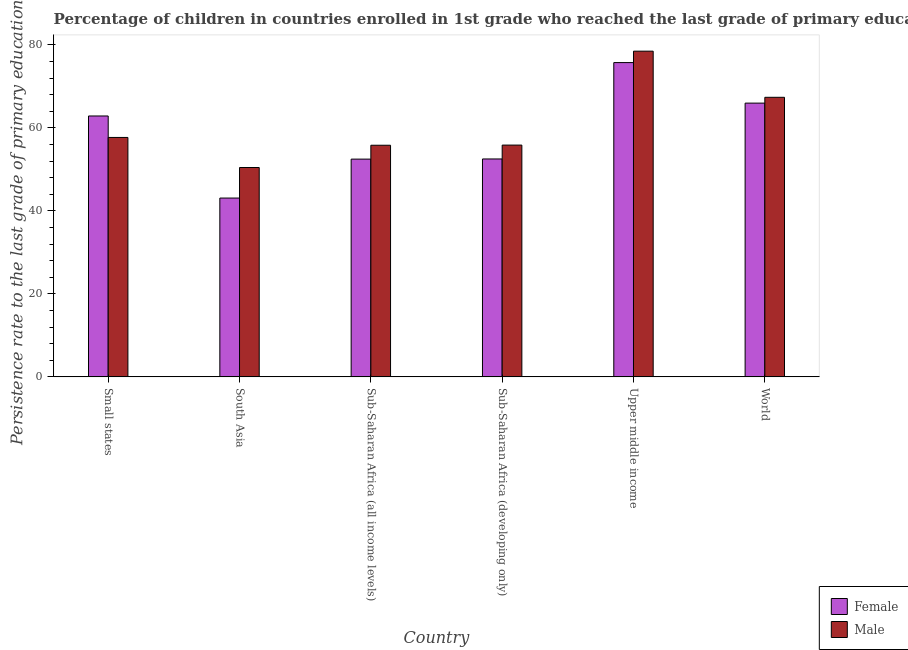Are the number of bars on each tick of the X-axis equal?
Your answer should be compact. Yes. What is the label of the 3rd group of bars from the left?
Offer a terse response. Sub-Saharan Africa (all income levels). What is the persistence rate of female students in Sub-Saharan Africa (all income levels)?
Offer a very short reply. 52.46. Across all countries, what is the maximum persistence rate of female students?
Your answer should be very brief. 75.72. Across all countries, what is the minimum persistence rate of female students?
Provide a short and direct response. 43.08. In which country was the persistence rate of male students maximum?
Ensure brevity in your answer.  Upper middle income. In which country was the persistence rate of male students minimum?
Provide a short and direct response. South Asia. What is the total persistence rate of male students in the graph?
Make the answer very short. 365.6. What is the difference between the persistence rate of female students in South Asia and that in World?
Make the answer very short. -22.87. What is the difference between the persistence rate of male students in South Asia and the persistence rate of female students in World?
Your answer should be very brief. -15.51. What is the average persistence rate of male students per country?
Offer a very short reply. 60.93. What is the difference between the persistence rate of male students and persistence rate of female students in South Asia?
Give a very brief answer. 7.36. What is the ratio of the persistence rate of female students in Sub-Saharan Africa (all income levels) to that in Sub-Saharan Africa (developing only)?
Your answer should be compact. 1. Is the persistence rate of female students in South Asia less than that in Sub-Saharan Africa (all income levels)?
Provide a succinct answer. Yes. Is the difference between the persistence rate of female students in Sub-Saharan Africa (all income levels) and World greater than the difference between the persistence rate of male students in Sub-Saharan Africa (all income levels) and World?
Ensure brevity in your answer.  No. What is the difference between the highest and the second highest persistence rate of female students?
Your response must be concise. 9.77. What is the difference between the highest and the lowest persistence rate of male students?
Ensure brevity in your answer.  28.03. Is the sum of the persistence rate of male students in Sub-Saharan Africa (all income levels) and Upper middle income greater than the maximum persistence rate of female students across all countries?
Your response must be concise. Yes. What does the 1st bar from the left in Upper middle income represents?
Your answer should be compact. Female. What does the 1st bar from the right in Sub-Saharan Africa (developing only) represents?
Give a very brief answer. Male. Are all the bars in the graph horizontal?
Give a very brief answer. No. What is the difference between two consecutive major ticks on the Y-axis?
Your answer should be compact. 20. Are the values on the major ticks of Y-axis written in scientific E-notation?
Give a very brief answer. No. Where does the legend appear in the graph?
Ensure brevity in your answer.  Bottom right. How many legend labels are there?
Keep it short and to the point. 2. What is the title of the graph?
Give a very brief answer. Percentage of children in countries enrolled in 1st grade who reached the last grade of primary education. Does "All education staff compensation" appear as one of the legend labels in the graph?
Your response must be concise. No. What is the label or title of the Y-axis?
Keep it short and to the point. Persistence rate to the last grade of primary education (%). What is the Persistence rate to the last grade of primary education (%) of Female in Small states?
Give a very brief answer. 62.85. What is the Persistence rate to the last grade of primary education (%) in Male in Small states?
Offer a terse response. 57.68. What is the Persistence rate to the last grade of primary education (%) in Female in South Asia?
Provide a succinct answer. 43.08. What is the Persistence rate to the last grade of primary education (%) in Male in South Asia?
Give a very brief answer. 50.44. What is the Persistence rate to the last grade of primary education (%) in Female in Sub-Saharan Africa (all income levels)?
Make the answer very short. 52.46. What is the Persistence rate to the last grade of primary education (%) in Male in Sub-Saharan Africa (all income levels)?
Give a very brief answer. 55.81. What is the Persistence rate to the last grade of primary education (%) in Female in Sub-Saharan Africa (developing only)?
Make the answer very short. 52.5. What is the Persistence rate to the last grade of primary education (%) of Male in Sub-Saharan Africa (developing only)?
Ensure brevity in your answer.  55.84. What is the Persistence rate to the last grade of primary education (%) of Female in Upper middle income?
Make the answer very short. 75.72. What is the Persistence rate to the last grade of primary education (%) of Male in Upper middle income?
Provide a short and direct response. 78.47. What is the Persistence rate to the last grade of primary education (%) of Female in World?
Provide a short and direct response. 65.95. What is the Persistence rate to the last grade of primary education (%) of Male in World?
Your answer should be very brief. 67.35. Across all countries, what is the maximum Persistence rate to the last grade of primary education (%) of Female?
Keep it short and to the point. 75.72. Across all countries, what is the maximum Persistence rate to the last grade of primary education (%) of Male?
Offer a very short reply. 78.47. Across all countries, what is the minimum Persistence rate to the last grade of primary education (%) of Female?
Provide a succinct answer. 43.08. Across all countries, what is the minimum Persistence rate to the last grade of primary education (%) of Male?
Provide a succinct answer. 50.44. What is the total Persistence rate to the last grade of primary education (%) of Female in the graph?
Provide a short and direct response. 352.57. What is the total Persistence rate to the last grade of primary education (%) of Male in the graph?
Keep it short and to the point. 365.6. What is the difference between the Persistence rate to the last grade of primary education (%) of Female in Small states and that in South Asia?
Make the answer very short. 19.77. What is the difference between the Persistence rate to the last grade of primary education (%) in Male in Small states and that in South Asia?
Provide a short and direct response. 7.24. What is the difference between the Persistence rate to the last grade of primary education (%) in Female in Small states and that in Sub-Saharan Africa (all income levels)?
Your answer should be compact. 10.39. What is the difference between the Persistence rate to the last grade of primary education (%) of Male in Small states and that in Sub-Saharan Africa (all income levels)?
Provide a succinct answer. 1.88. What is the difference between the Persistence rate to the last grade of primary education (%) in Female in Small states and that in Sub-Saharan Africa (developing only)?
Keep it short and to the point. 10.35. What is the difference between the Persistence rate to the last grade of primary education (%) of Male in Small states and that in Sub-Saharan Africa (developing only)?
Give a very brief answer. 1.84. What is the difference between the Persistence rate to the last grade of primary education (%) in Female in Small states and that in Upper middle income?
Keep it short and to the point. -12.87. What is the difference between the Persistence rate to the last grade of primary education (%) of Male in Small states and that in Upper middle income?
Your answer should be very brief. -20.79. What is the difference between the Persistence rate to the last grade of primary education (%) of Female in Small states and that in World?
Your answer should be compact. -3.1. What is the difference between the Persistence rate to the last grade of primary education (%) in Male in Small states and that in World?
Offer a very short reply. -9.67. What is the difference between the Persistence rate to the last grade of primary education (%) in Female in South Asia and that in Sub-Saharan Africa (all income levels)?
Provide a short and direct response. -9.38. What is the difference between the Persistence rate to the last grade of primary education (%) of Male in South Asia and that in Sub-Saharan Africa (all income levels)?
Keep it short and to the point. -5.36. What is the difference between the Persistence rate to the last grade of primary education (%) in Female in South Asia and that in Sub-Saharan Africa (developing only)?
Provide a succinct answer. -9.42. What is the difference between the Persistence rate to the last grade of primary education (%) in Male in South Asia and that in Sub-Saharan Africa (developing only)?
Make the answer very short. -5.4. What is the difference between the Persistence rate to the last grade of primary education (%) of Female in South Asia and that in Upper middle income?
Ensure brevity in your answer.  -32.64. What is the difference between the Persistence rate to the last grade of primary education (%) in Male in South Asia and that in Upper middle income?
Your response must be concise. -28.03. What is the difference between the Persistence rate to the last grade of primary education (%) of Female in South Asia and that in World?
Your answer should be compact. -22.87. What is the difference between the Persistence rate to the last grade of primary education (%) of Male in South Asia and that in World?
Provide a short and direct response. -16.91. What is the difference between the Persistence rate to the last grade of primary education (%) in Female in Sub-Saharan Africa (all income levels) and that in Sub-Saharan Africa (developing only)?
Offer a very short reply. -0.04. What is the difference between the Persistence rate to the last grade of primary education (%) in Male in Sub-Saharan Africa (all income levels) and that in Sub-Saharan Africa (developing only)?
Make the answer very short. -0.04. What is the difference between the Persistence rate to the last grade of primary education (%) in Female in Sub-Saharan Africa (all income levels) and that in Upper middle income?
Your answer should be very brief. -23.26. What is the difference between the Persistence rate to the last grade of primary education (%) of Male in Sub-Saharan Africa (all income levels) and that in Upper middle income?
Provide a short and direct response. -22.67. What is the difference between the Persistence rate to the last grade of primary education (%) in Female in Sub-Saharan Africa (all income levels) and that in World?
Your answer should be very brief. -13.49. What is the difference between the Persistence rate to the last grade of primary education (%) of Male in Sub-Saharan Africa (all income levels) and that in World?
Offer a terse response. -11.55. What is the difference between the Persistence rate to the last grade of primary education (%) of Female in Sub-Saharan Africa (developing only) and that in Upper middle income?
Offer a terse response. -23.22. What is the difference between the Persistence rate to the last grade of primary education (%) in Male in Sub-Saharan Africa (developing only) and that in Upper middle income?
Give a very brief answer. -22.63. What is the difference between the Persistence rate to the last grade of primary education (%) in Female in Sub-Saharan Africa (developing only) and that in World?
Offer a terse response. -13.45. What is the difference between the Persistence rate to the last grade of primary education (%) of Male in Sub-Saharan Africa (developing only) and that in World?
Your response must be concise. -11.51. What is the difference between the Persistence rate to the last grade of primary education (%) in Female in Upper middle income and that in World?
Make the answer very short. 9.77. What is the difference between the Persistence rate to the last grade of primary education (%) in Male in Upper middle income and that in World?
Offer a terse response. 11.12. What is the difference between the Persistence rate to the last grade of primary education (%) in Female in Small states and the Persistence rate to the last grade of primary education (%) in Male in South Asia?
Give a very brief answer. 12.41. What is the difference between the Persistence rate to the last grade of primary education (%) in Female in Small states and the Persistence rate to the last grade of primary education (%) in Male in Sub-Saharan Africa (all income levels)?
Provide a short and direct response. 7.05. What is the difference between the Persistence rate to the last grade of primary education (%) of Female in Small states and the Persistence rate to the last grade of primary education (%) of Male in Sub-Saharan Africa (developing only)?
Give a very brief answer. 7.01. What is the difference between the Persistence rate to the last grade of primary education (%) in Female in Small states and the Persistence rate to the last grade of primary education (%) in Male in Upper middle income?
Ensure brevity in your answer.  -15.62. What is the difference between the Persistence rate to the last grade of primary education (%) of Female in Small states and the Persistence rate to the last grade of primary education (%) of Male in World?
Keep it short and to the point. -4.5. What is the difference between the Persistence rate to the last grade of primary education (%) in Female in South Asia and the Persistence rate to the last grade of primary education (%) in Male in Sub-Saharan Africa (all income levels)?
Your answer should be compact. -12.73. What is the difference between the Persistence rate to the last grade of primary education (%) of Female in South Asia and the Persistence rate to the last grade of primary education (%) of Male in Sub-Saharan Africa (developing only)?
Your answer should be very brief. -12.76. What is the difference between the Persistence rate to the last grade of primary education (%) of Female in South Asia and the Persistence rate to the last grade of primary education (%) of Male in Upper middle income?
Offer a very short reply. -35.39. What is the difference between the Persistence rate to the last grade of primary education (%) of Female in South Asia and the Persistence rate to the last grade of primary education (%) of Male in World?
Offer a terse response. -24.27. What is the difference between the Persistence rate to the last grade of primary education (%) of Female in Sub-Saharan Africa (all income levels) and the Persistence rate to the last grade of primary education (%) of Male in Sub-Saharan Africa (developing only)?
Provide a succinct answer. -3.38. What is the difference between the Persistence rate to the last grade of primary education (%) in Female in Sub-Saharan Africa (all income levels) and the Persistence rate to the last grade of primary education (%) in Male in Upper middle income?
Provide a short and direct response. -26.01. What is the difference between the Persistence rate to the last grade of primary education (%) of Female in Sub-Saharan Africa (all income levels) and the Persistence rate to the last grade of primary education (%) of Male in World?
Make the answer very short. -14.89. What is the difference between the Persistence rate to the last grade of primary education (%) in Female in Sub-Saharan Africa (developing only) and the Persistence rate to the last grade of primary education (%) in Male in Upper middle income?
Offer a very short reply. -25.97. What is the difference between the Persistence rate to the last grade of primary education (%) of Female in Sub-Saharan Africa (developing only) and the Persistence rate to the last grade of primary education (%) of Male in World?
Ensure brevity in your answer.  -14.85. What is the difference between the Persistence rate to the last grade of primary education (%) in Female in Upper middle income and the Persistence rate to the last grade of primary education (%) in Male in World?
Your answer should be compact. 8.37. What is the average Persistence rate to the last grade of primary education (%) of Female per country?
Offer a very short reply. 58.76. What is the average Persistence rate to the last grade of primary education (%) in Male per country?
Your response must be concise. 60.93. What is the difference between the Persistence rate to the last grade of primary education (%) of Female and Persistence rate to the last grade of primary education (%) of Male in Small states?
Offer a terse response. 5.17. What is the difference between the Persistence rate to the last grade of primary education (%) of Female and Persistence rate to the last grade of primary education (%) of Male in South Asia?
Offer a very short reply. -7.36. What is the difference between the Persistence rate to the last grade of primary education (%) of Female and Persistence rate to the last grade of primary education (%) of Male in Sub-Saharan Africa (all income levels)?
Offer a very short reply. -3.34. What is the difference between the Persistence rate to the last grade of primary education (%) in Female and Persistence rate to the last grade of primary education (%) in Male in Sub-Saharan Africa (developing only)?
Your answer should be very brief. -3.34. What is the difference between the Persistence rate to the last grade of primary education (%) of Female and Persistence rate to the last grade of primary education (%) of Male in Upper middle income?
Provide a succinct answer. -2.75. What is the difference between the Persistence rate to the last grade of primary education (%) of Female and Persistence rate to the last grade of primary education (%) of Male in World?
Your response must be concise. -1.4. What is the ratio of the Persistence rate to the last grade of primary education (%) of Female in Small states to that in South Asia?
Offer a terse response. 1.46. What is the ratio of the Persistence rate to the last grade of primary education (%) of Male in Small states to that in South Asia?
Make the answer very short. 1.14. What is the ratio of the Persistence rate to the last grade of primary education (%) in Female in Small states to that in Sub-Saharan Africa (all income levels)?
Offer a very short reply. 1.2. What is the ratio of the Persistence rate to the last grade of primary education (%) in Male in Small states to that in Sub-Saharan Africa (all income levels)?
Keep it short and to the point. 1.03. What is the ratio of the Persistence rate to the last grade of primary education (%) in Female in Small states to that in Sub-Saharan Africa (developing only)?
Your answer should be compact. 1.2. What is the ratio of the Persistence rate to the last grade of primary education (%) in Male in Small states to that in Sub-Saharan Africa (developing only)?
Your answer should be very brief. 1.03. What is the ratio of the Persistence rate to the last grade of primary education (%) of Female in Small states to that in Upper middle income?
Give a very brief answer. 0.83. What is the ratio of the Persistence rate to the last grade of primary education (%) in Male in Small states to that in Upper middle income?
Offer a terse response. 0.74. What is the ratio of the Persistence rate to the last grade of primary education (%) of Female in Small states to that in World?
Ensure brevity in your answer.  0.95. What is the ratio of the Persistence rate to the last grade of primary education (%) of Male in Small states to that in World?
Offer a terse response. 0.86. What is the ratio of the Persistence rate to the last grade of primary education (%) in Female in South Asia to that in Sub-Saharan Africa (all income levels)?
Offer a very short reply. 0.82. What is the ratio of the Persistence rate to the last grade of primary education (%) of Male in South Asia to that in Sub-Saharan Africa (all income levels)?
Your answer should be compact. 0.9. What is the ratio of the Persistence rate to the last grade of primary education (%) of Female in South Asia to that in Sub-Saharan Africa (developing only)?
Provide a succinct answer. 0.82. What is the ratio of the Persistence rate to the last grade of primary education (%) in Male in South Asia to that in Sub-Saharan Africa (developing only)?
Keep it short and to the point. 0.9. What is the ratio of the Persistence rate to the last grade of primary education (%) in Female in South Asia to that in Upper middle income?
Your response must be concise. 0.57. What is the ratio of the Persistence rate to the last grade of primary education (%) of Male in South Asia to that in Upper middle income?
Make the answer very short. 0.64. What is the ratio of the Persistence rate to the last grade of primary education (%) in Female in South Asia to that in World?
Your response must be concise. 0.65. What is the ratio of the Persistence rate to the last grade of primary education (%) in Male in South Asia to that in World?
Keep it short and to the point. 0.75. What is the ratio of the Persistence rate to the last grade of primary education (%) of Female in Sub-Saharan Africa (all income levels) to that in Sub-Saharan Africa (developing only)?
Keep it short and to the point. 1. What is the ratio of the Persistence rate to the last grade of primary education (%) in Male in Sub-Saharan Africa (all income levels) to that in Sub-Saharan Africa (developing only)?
Provide a short and direct response. 1. What is the ratio of the Persistence rate to the last grade of primary education (%) of Female in Sub-Saharan Africa (all income levels) to that in Upper middle income?
Offer a very short reply. 0.69. What is the ratio of the Persistence rate to the last grade of primary education (%) of Male in Sub-Saharan Africa (all income levels) to that in Upper middle income?
Provide a short and direct response. 0.71. What is the ratio of the Persistence rate to the last grade of primary education (%) of Female in Sub-Saharan Africa (all income levels) to that in World?
Offer a terse response. 0.8. What is the ratio of the Persistence rate to the last grade of primary education (%) in Male in Sub-Saharan Africa (all income levels) to that in World?
Offer a terse response. 0.83. What is the ratio of the Persistence rate to the last grade of primary education (%) in Female in Sub-Saharan Africa (developing only) to that in Upper middle income?
Give a very brief answer. 0.69. What is the ratio of the Persistence rate to the last grade of primary education (%) in Male in Sub-Saharan Africa (developing only) to that in Upper middle income?
Provide a succinct answer. 0.71. What is the ratio of the Persistence rate to the last grade of primary education (%) of Female in Sub-Saharan Africa (developing only) to that in World?
Provide a succinct answer. 0.8. What is the ratio of the Persistence rate to the last grade of primary education (%) of Male in Sub-Saharan Africa (developing only) to that in World?
Give a very brief answer. 0.83. What is the ratio of the Persistence rate to the last grade of primary education (%) of Female in Upper middle income to that in World?
Ensure brevity in your answer.  1.15. What is the ratio of the Persistence rate to the last grade of primary education (%) of Male in Upper middle income to that in World?
Provide a succinct answer. 1.17. What is the difference between the highest and the second highest Persistence rate to the last grade of primary education (%) in Female?
Give a very brief answer. 9.77. What is the difference between the highest and the second highest Persistence rate to the last grade of primary education (%) of Male?
Keep it short and to the point. 11.12. What is the difference between the highest and the lowest Persistence rate to the last grade of primary education (%) of Female?
Keep it short and to the point. 32.64. What is the difference between the highest and the lowest Persistence rate to the last grade of primary education (%) of Male?
Offer a very short reply. 28.03. 